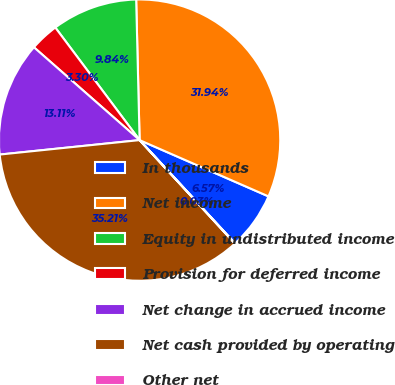<chart> <loc_0><loc_0><loc_500><loc_500><pie_chart><fcel>In thousands<fcel>Net income<fcel>Equity in undistributed income<fcel>Provision for deferred income<fcel>Net change in accrued income<fcel>Net cash provided by operating<fcel>Other net<nl><fcel>6.57%<fcel>31.94%<fcel>9.84%<fcel>3.3%<fcel>13.11%<fcel>35.21%<fcel>0.03%<nl></chart> 